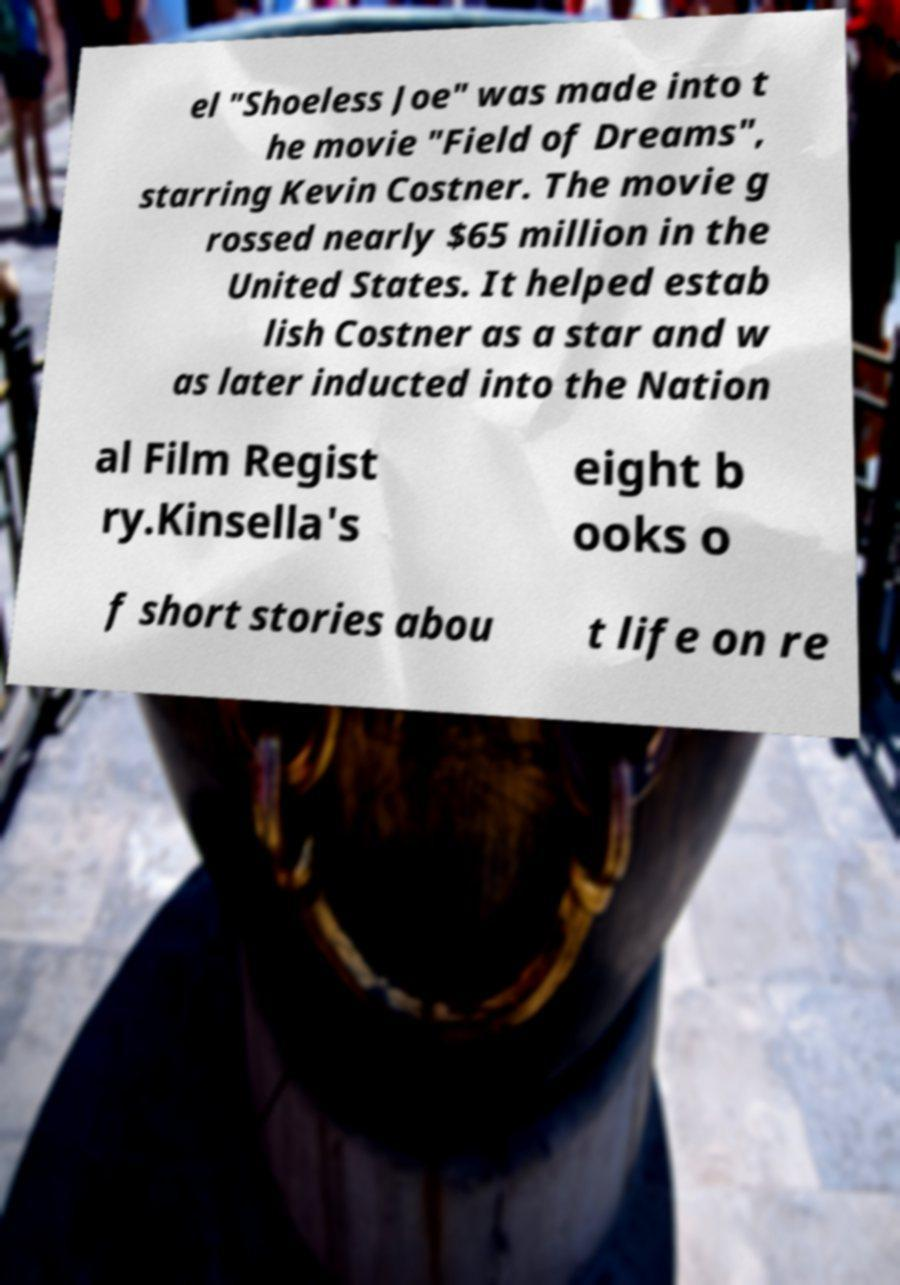Please identify and transcribe the text found in this image. el "Shoeless Joe" was made into t he movie "Field of Dreams", starring Kevin Costner. The movie g rossed nearly $65 million in the United States. It helped estab lish Costner as a star and w as later inducted into the Nation al Film Regist ry.Kinsella's eight b ooks o f short stories abou t life on re 